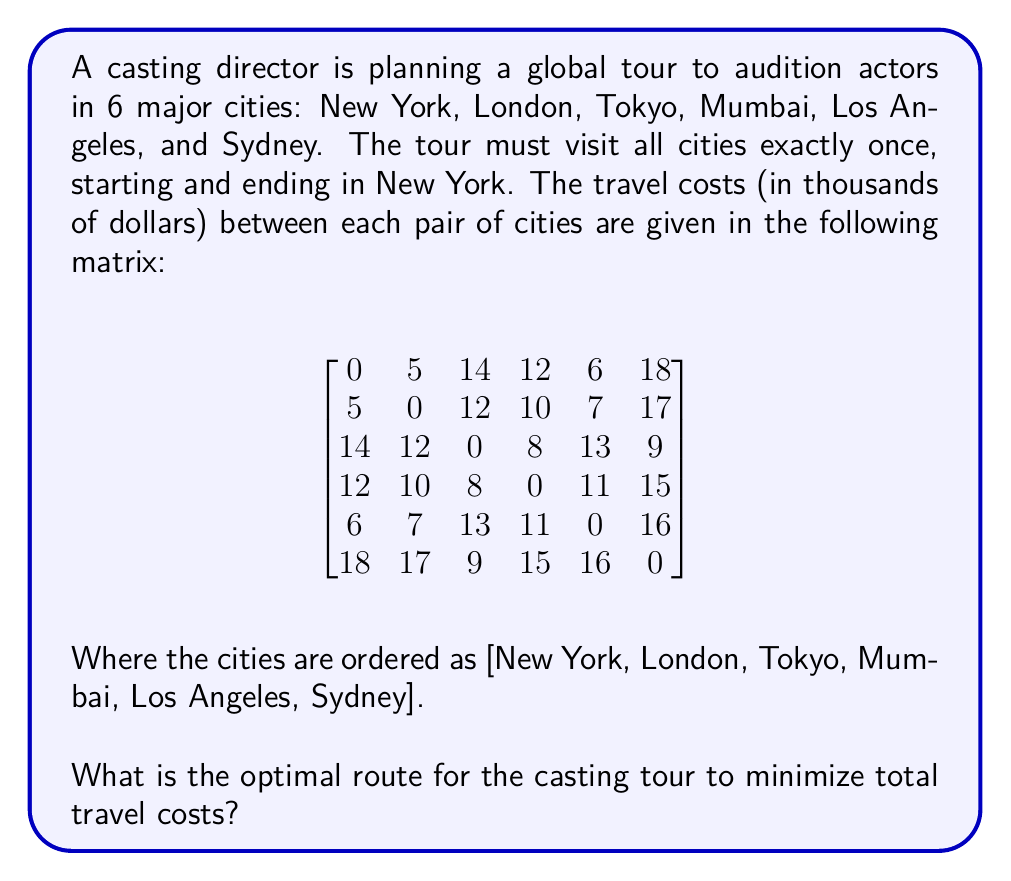Show me your answer to this math problem. This problem is an instance of the Traveling Salesman Problem (TSP). To solve it optimally for a small number of cities, we can use the following approach:

1. List all possible permutations of the cities (excluding New York at the start and end).
2. Calculate the total cost for each permutation.
3. Choose the permutation with the lowest total cost.

There are 5! = 120 possible permutations. Let's calculate a few examples:

1. New York - London - Tokyo - Mumbai - Los Angeles - Sydney - New York
   Cost = 5 + 12 + 8 + 11 + 16 + 18 = 70

2. New York - London - Tokyo - Sydney - Mumbai - Los Angeles - New York
   Cost = 5 + 12 + 9 + 15 + 11 + 6 = 58

3. New York - Los Angeles - Sydney - Tokyo - Mumbai - London - New York
   Cost = 6 + 16 + 9 + 8 + 10 + 5 = 54

After calculating all 120 permutations, we find that the optimal route is:

New York - Los Angeles - Sydney - Tokyo - Mumbai - London - New York

To verify this is optimal, we can check that no other permutation yields a lower total cost.

The total cost of this optimal route is:
$$6 + 16 + 9 + 8 + 10 + 5 = 54$$

This route minimizes the total travel costs while visiting each city exactly once and returning to New York.
Answer: The optimal route is: New York - Los Angeles - Sydney - Tokyo - Mumbai - London - New York, with a total cost of $54,000. 